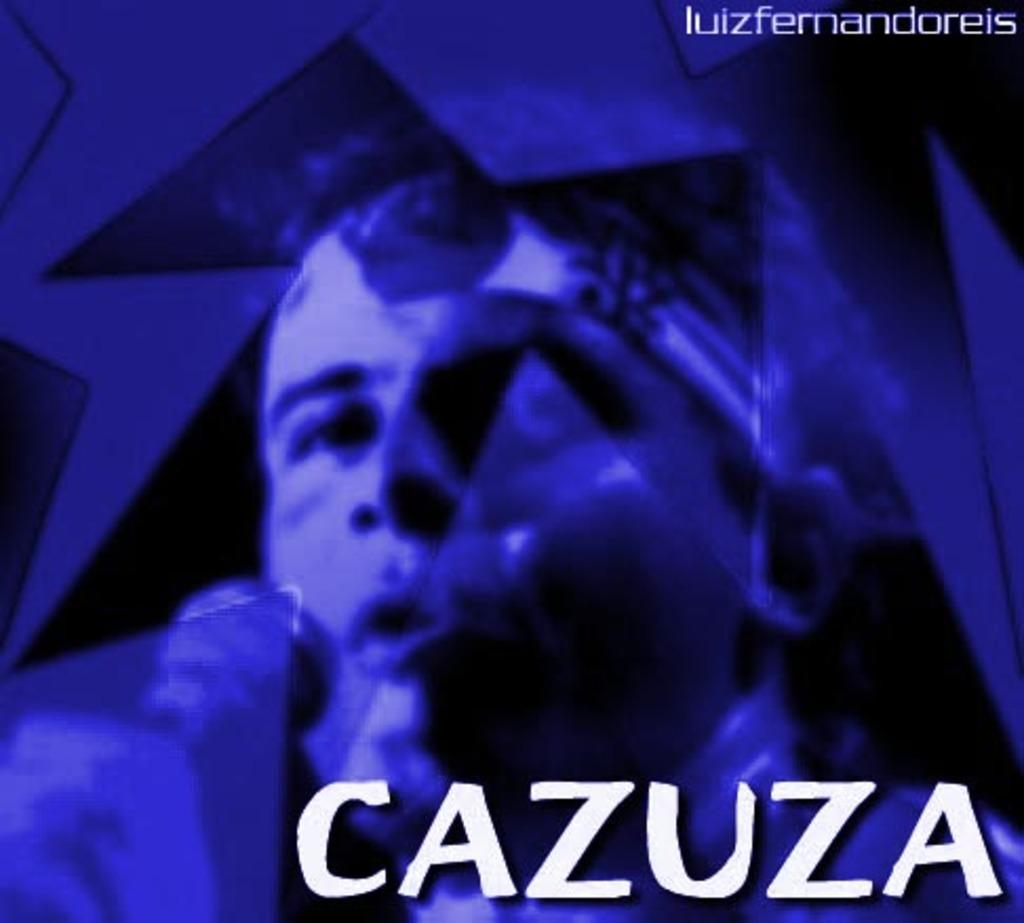What is the main subject of the image? There is a person in the image. What is the person holding in the image? The person is holding a microphone. Can you describe any additional features of the image? There are watermarks on the image. What type of bait is the person using to catch fish in the image? There is no indication of fishing or bait in the image; the person is holding a microphone. Can you describe the feather on the person's hat in the image? There is no hat or feather visible in the image. 